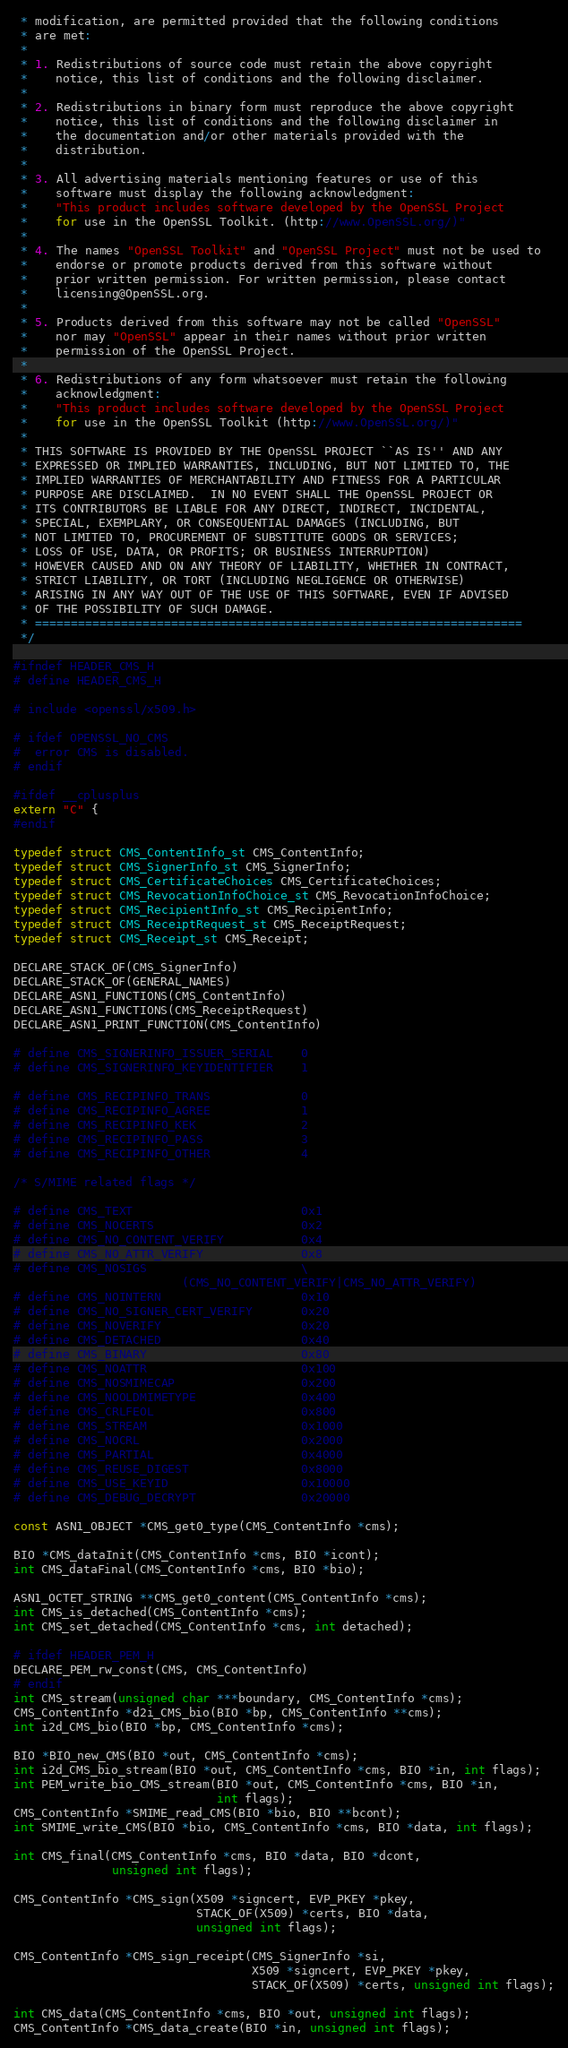Convert code to text. <code><loc_0><loc_0><loc_500><loc_500><_C_> * modification, are permitted provided that the following conditions
 * are met:
 *
 * 1. Redistributions of source code must retain the above copyright
 *    notice, this list of conditions and the following disclaimer.
 *
 * 2. Redistributions in binary form must reproduce the above copyright
 *    notice, this list of conditions and the following disclaimer in
 *    the documentation and/or other materials provided with the
 *    distribution.
 *
 * 3. All advertising materials mentioning features or use of this
 *    software must display the following acknowledgment:
 *    "This product includes software developed by the OpenSSL Project
 *    for use in the OpenSSL Toolkit. (http://www.OpenSSL.org/)"
 *
 * 4. The names "OpenSSL Toolkit" and "OpenSSL Project" must not be used to
 *    endorse or promote products derived from this software without
 *    prior written permission. For written permission, please contact
 *    licensing@OpenSSL.org.
 *
 * 5. Products derived from this software may not be called "OpenSSL"
 *    nor may "OpenSSL" appear in their names without prior written
 *    permission of the OpenSSL Project.
 *
 * 6. Redistributions of any form whatsoever must retain the following
 *    acknowledgment:
 *    "This product includes software developed by the OpenSSL Project
 *    for use in the OpenSSL Toolkit (http://www.OpenSSL.org/)"
 *
 * THIS SOFTWARE IS PROVIDED BY THE OpenSSL PROJECT ``AS IS'' AND ANY
 * EXPRESSED OR IMPLIED WARRANTIES, INCLUDING, BUT NOT LIMITED TO, THE
 * IMPLIED WARRANTIES OF MERCHANTABILITY AND FITNESS FOR A PARTICULAR
 * PURPOSE ARE DISCLAIMED.  IN NO EVENT SHALL THE OpenSSL PROJECT OR
 * ITS CONTRIBUTORS BE LIABLE FOR ANY DIRECT, INDIRECT, INCIDENTAL,
 * SPECIAL, EXEMPLARY, OR CONSEQUENTIAL DAMAGES (INCLUDING, BUT
 * NOT LIMITED TO, PROCUREMENT OF SUBSTITUTE GOODS OR SERVICES;
 * LOSS OF USE, DATA, OR PROFITS; OR BUSINESS INTERRUPTION)
 * HOWEVER CAUSED AND ON ANY THEORY OF LIABILITY, WHETHER IN CONTRACT,
 * STRICT LIABILITY, OR TORT (INCLUDING NEGLIGENCE OR OTHERWISE)
 * ARISING IN ANY WAY OUT OF THE USE OF THIS SOFTWARE, EVEN IF ADVISED
 * OF THE POSSIBILITY OF SUCH DAMAGE.
 * ====================================================================
 */

#ifndef HEADER_CMS_H
# define HEADER_CMS_H

# include <openssl/x509.h>

# ifdef OPENSSL_NO_CMS
#  error CMS is disabled.
# endif

#ifdef __cplusplus
extern "C" {
#endif

typedef struct CMS_ContentInfo_st CMS_ContentInfo;
typedef struct CMS_SignerInfo_st CMS_SignerInfo;
typedef struct CMS_CertificateChoices CMS_CertificateChoices;
typedef struct CMS_RevocationInfoChoice_st CMS_RevocationInfoChoice;
typedef struct CMS_RecipientInfo_st CMS_RecipientInfo;
typedef struct CMS_ReceiptRequest_st CMS_ReceiptRequest;
typedef struct CMS_Receipt_st CMS_Receipt;

DECLARE_STACK_OF(CMS_SignerInfo)
DECLARE_STACK_OF(GENERAL_NAMES)
DECLARE_ASN1_FUNCTIONS(CMS_ContentInfo)
DECLARE_ASN1_FUNCTIONS(CMS_ReceiptRequest)
DECLARE_ASN1_PRINT_FUNCTION(CMS_ContentInfo)

# define CMS_SIGNERINFO_ISSUER_SERIAL    0
# define CMS_SIGNERINFO_KEYIDENTIFIER    1

# define CMS_RECIPINFO_TRANS             0
# define CMS_RECIPINFO_AGREE             1
# define CMS_RECIPINFO_KEK               2
# define CMS_RECIPINFO_PASS              3
# define CMS_RECIPINFO_OTHER             4

/* S/MIME related flags */

# define CMS_TEXT                        0x1
# define CMS_NOCERTS                     0x2
# define CMS_NO_CONTENT_VERIFY           0x4
# define CMS_NO_ATTR_VERIFY              0x8
# define CMS_NOSIGS                      \
                        (CMS_NO_CONTENT_VERIFY|CMS_NO_ATTR_VERIFY)
# define CMS_NOINTERN                    0x10
# define CMS_NO_SIGNER_CERT_VERIFY       0x20
# define CMS_NOVERIFY                    0x20
# define CMS_DETACHED                    0x40
# define CMS_BINARY                      0x80
# define CMS_NOATTR                      0x100
# define CMS_NOSMIMECAP                  0x200
# define CMS_NOOLDMIMETYPE               0x400
# define CMS_CRLFEOL                     0x800
# define CMS_STREAM                      0x1000
# define CMS_NOCRL                       0x2000
# define CMS_PARTIAL                     0x4000
# define CMS_REUSE_DIGEST                0x8000
# define CMS_USE_KEYID                   0x10000
# define CMS_DEBUG_DECRYPT               0x20000

const ASN1_OBJECT *CMS_get0_type(CMS_ContentInfo *cms);

BIO *CMS_dataInit(CMS_ContentInfo *cms, BIO *icont);
int CMS_dataFinal(CMS_ContentInfo *cms, BIO *bio);

ASN1_OCTET_STRING **CMS_get0_content(CMS_ContentInfo *cms);
int CMS_is_detached(CMS_ContentInfo *cms);
int CMS_set_detached(CMS_ContentInfo *cms, int detached);

# ifdef HEADER_PEM_H
DECLARE_PEM_rw_const(CMS, CMS_ContentInfo)
# endif
int CMS_stream(unsigned char ***boundary, CMS_ContentInfo *cms);
CMS_ContentInfo *d2i_CMS_bio(BIO *bp, CMS_ContentInfo **cms);
int i2d_CMS_bio(BIO *bp, CMS_ContentInfo *cms);

BIO *BIO_new_CMS(BIO *out, CMS_ContentInfo *cms);
int i2d_CMS_bio_stream(BIO *out, CMS_ContentInfo *cms, BIO *in, int flags);
int PEM_write_bio_CMS_stream(BIO *out, CMS_ContentInfo *cms, BIO *in,
                             int flags);
CMS_ContentInfo *SMIME_read_CMS(BIO *bio, BIO **bcont);
int SMIME_write_CMS(BIO *bio, CMS_ContentInfo *cms, BIO *data, int flags);

int CMS_final(CMS_ContentInfo *cms, BIO *data, BIO *dcont,
              unsigned int flags);

CMS_ContentInfo *CMS_sign(X509 *signcert, EVP_PKEY *pkey,
                          STACK_OF(X509) *certs, BIO *data,
                          unsigned int flags);

CMS_ContentInfo *CMS_sign_receipt(CMS_SignerInfo *si,
                                  X509 *signcert, EVP_PKEY *pkey,
                                  STACK_OF(X509) *certs, unsigned int flags);

int CMS_data(CMS_ContentInfo *cms, BIO *out, unsigned int flags);
CMS_ContentInfo *CMS_data_create(BIO *in, unsigned int flags);
</code> 